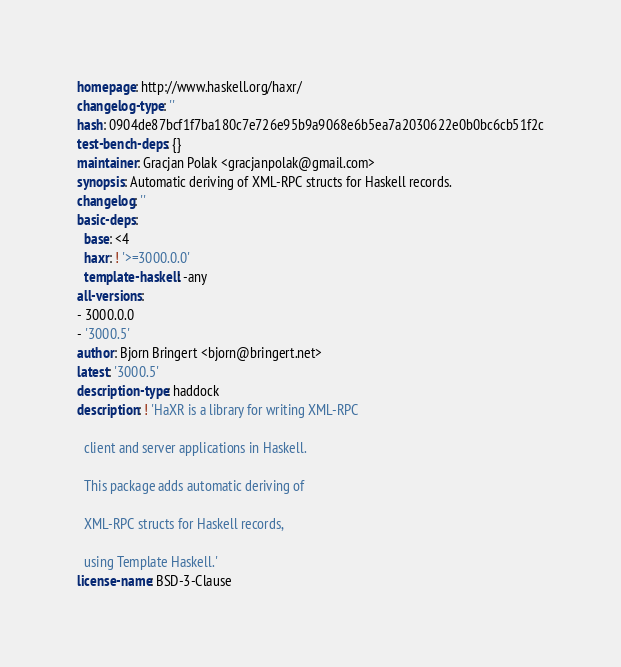<code> <loc_0><loc_0><loc_500><loc_500><_YAML_>homepage: http://www.haskell.org/haxr/
changelog-type: ''
hash: 0904de87bcf1f7ba180c7e726e95b9a9068e6b5ea7a2030622e0b0bc6cb51f2c
test-bench-deps: {}
maintainer: Gracjan Polak <gracjanpolak@gmail.com>
synopsis: Automatic deriving of XML-RPC structs for Haskell records.
changelog: ''
basic-deps:
  base: <4
  haxr: ! '>=3000.0.0'
  template-haskell: -any
all-versions:
- 3000.0.0
- '3000.5'
author: Bjorn Bringert <bjorn@bringert.net>
latest: '3000.5'
description-type: haddock
description: ! 'HaXR is a library for writing XML-RPC

  client and server applications in Haskell.

  This package adds automatic deriving of

  XML-RPC structs for Haskell records,

  using Template Haskell.'
license-name: BSD-3-Clause
</code> 